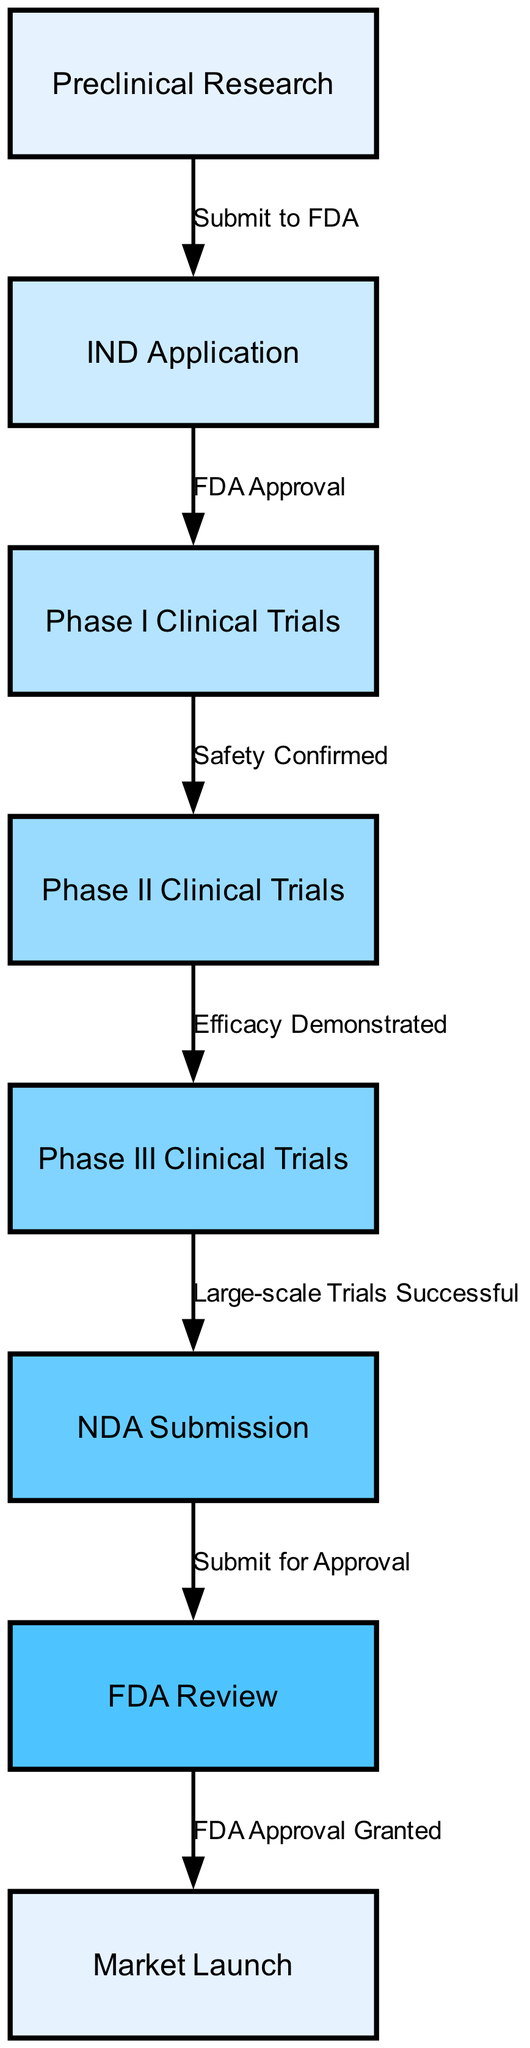What is the first step in the regulatory approval process? The first step is represented by the node labeled "Preclinical Research." This is where the process begins before any applications are made to the FDA.
Answer: Preclinical Research How many phases of clinical trials are there? The diagram indicates there are three distinct phases of clinical trials outlined: Phase I, Phase II, and Phase III. This is clearly shown as individual nodes in the flowchart.
Answer: Three What is the relationship between the "IND Application" and "Phase I Clinical Trials"? The relationship is indicated by the directed edge that connects "IND Application" to "Phase I Clinical Trials," labeled "FDA Approval," which signifies that the approval is necessary to move forward to clinical trials.
Answer: FDA Approval What is required after "Phase III Clinical Trials"? After Phase III Clinical Trials, the next step according to the diagram is "NDA Submission," which signifies the submission of the New Drug Application to the FDA for review.
Answer: NDA Submission Which step comes immediately after "FDA Review"? Immediately following "FDA Review" in the flowchart is "Market Launch," which represents the final step of the regulatory approval process, indicating the drug is available to the public after receiving approval.
Answer: Market Launch How many nodes are there in total in the diagram? The total number of nodes in the diagram is counted, and there are eight nodes representing different steps in the regulatory approval process for new pharmaceutical drugs.
Answer: Eight What must be demonstrated before advancing to "Phase III Clinical Trials"? Prior to advancing to "Phase III Clinical Trials," "Efficacy Demonstrated" must be established as indicated by the connection from "Phase II Clinical Trials" to "Phase III Clinical Trials."
Answer: Efficacy Demonstrated What confirms the safety of the drug after the first phase? The confirmation of the drug’s safety after "Phase I Clinical Trials" is indicated by the node labeled "Safety Confirmed," which shows that the initial clinical testing is successful before moving on.
Answer: Safety Confirmed Which node represents the final milestone before market launch? The final milestone before market launch is represented by the node "FDA Review," which is the last step prior to granting approval for the drug to be available in the market.
Answer: FDA Review 